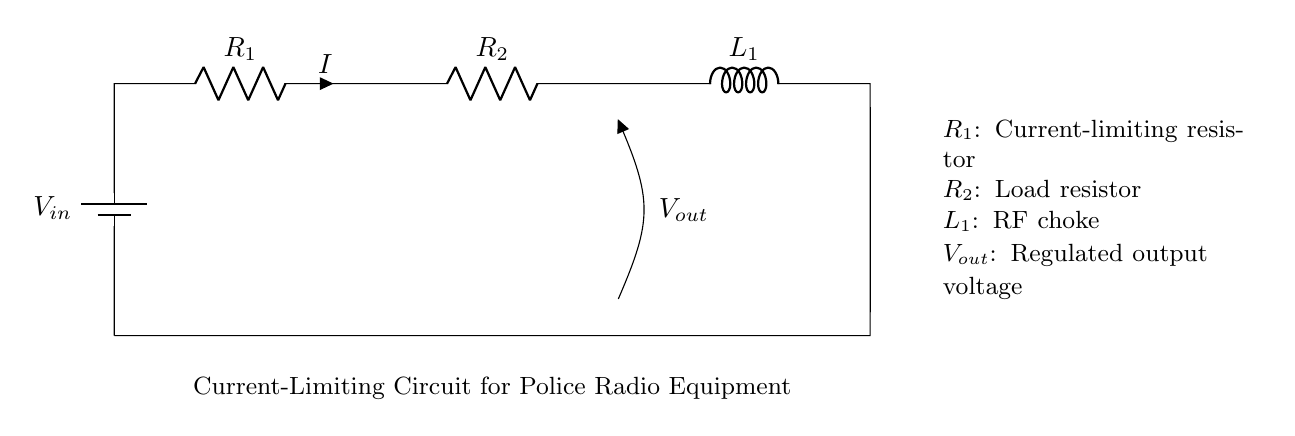What type of circuit is this? This is a current-limiting circuit designed to limit the current flowing to the police radio equipment. The presence of the current-limiting resistor and RF choke indicates its purpose to regulate current.
Answer: Current-limiting circuit What is the function of R1? R1 acts as a current-limiting resistor, which restricts the amount of current that can flow through the circuit, protecting the radio equipment from potential damage due to excessive current.
Answer: Current-limiting resistor What does Vout represent in this circuit? Vout represents the regulated output voltage provided to the radio equipment, ensuring that the device receives a consistent voltage level even under varying load conditions.
Answer: Regulated output voltage How many resistors are in this circuit? The circuit contains two resistors: R1 (current-limiting resistor) and R2 (load resistor). Both resistors are essential for the current regulation and load operation.
Answer: Two What is the purpose of the RF choke in this circuit? The RF choke (L1) is used to block high-frequency signals while allowing low-frequency current to pass. This helps prevent interference with the radio equipment's operation, ensuring better performance.
Answer: Block high-frequency signals What might happen if R1 is too low in value? If R1 has a low resistance value, excessive current may flow through the circuit, potentially damaging the police radio equipment or causing it to malfunction due to overcurrent conditions.
Answer: Excessive current flow 